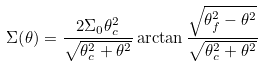Convert formula to latex. <formula><loc_0><loc_0><loc_500><loc_500>\Sigma { \left ( \theta \right ) } = \frac { 2 \Sigma _ { 0 } \theta _ { c } ^ { 2 } } { \sqrt { \theta _ { c } ^ { 2 } + \theta ^ { 2 } } } \arctan { \frac { \sqrt { \theta _ { f } ^ { 2 } - \theta ^ { 2 } } } { \sqrt { \theta _ { c } ^ { 2 } + \theta ^ { 2 } } } }</formula> 